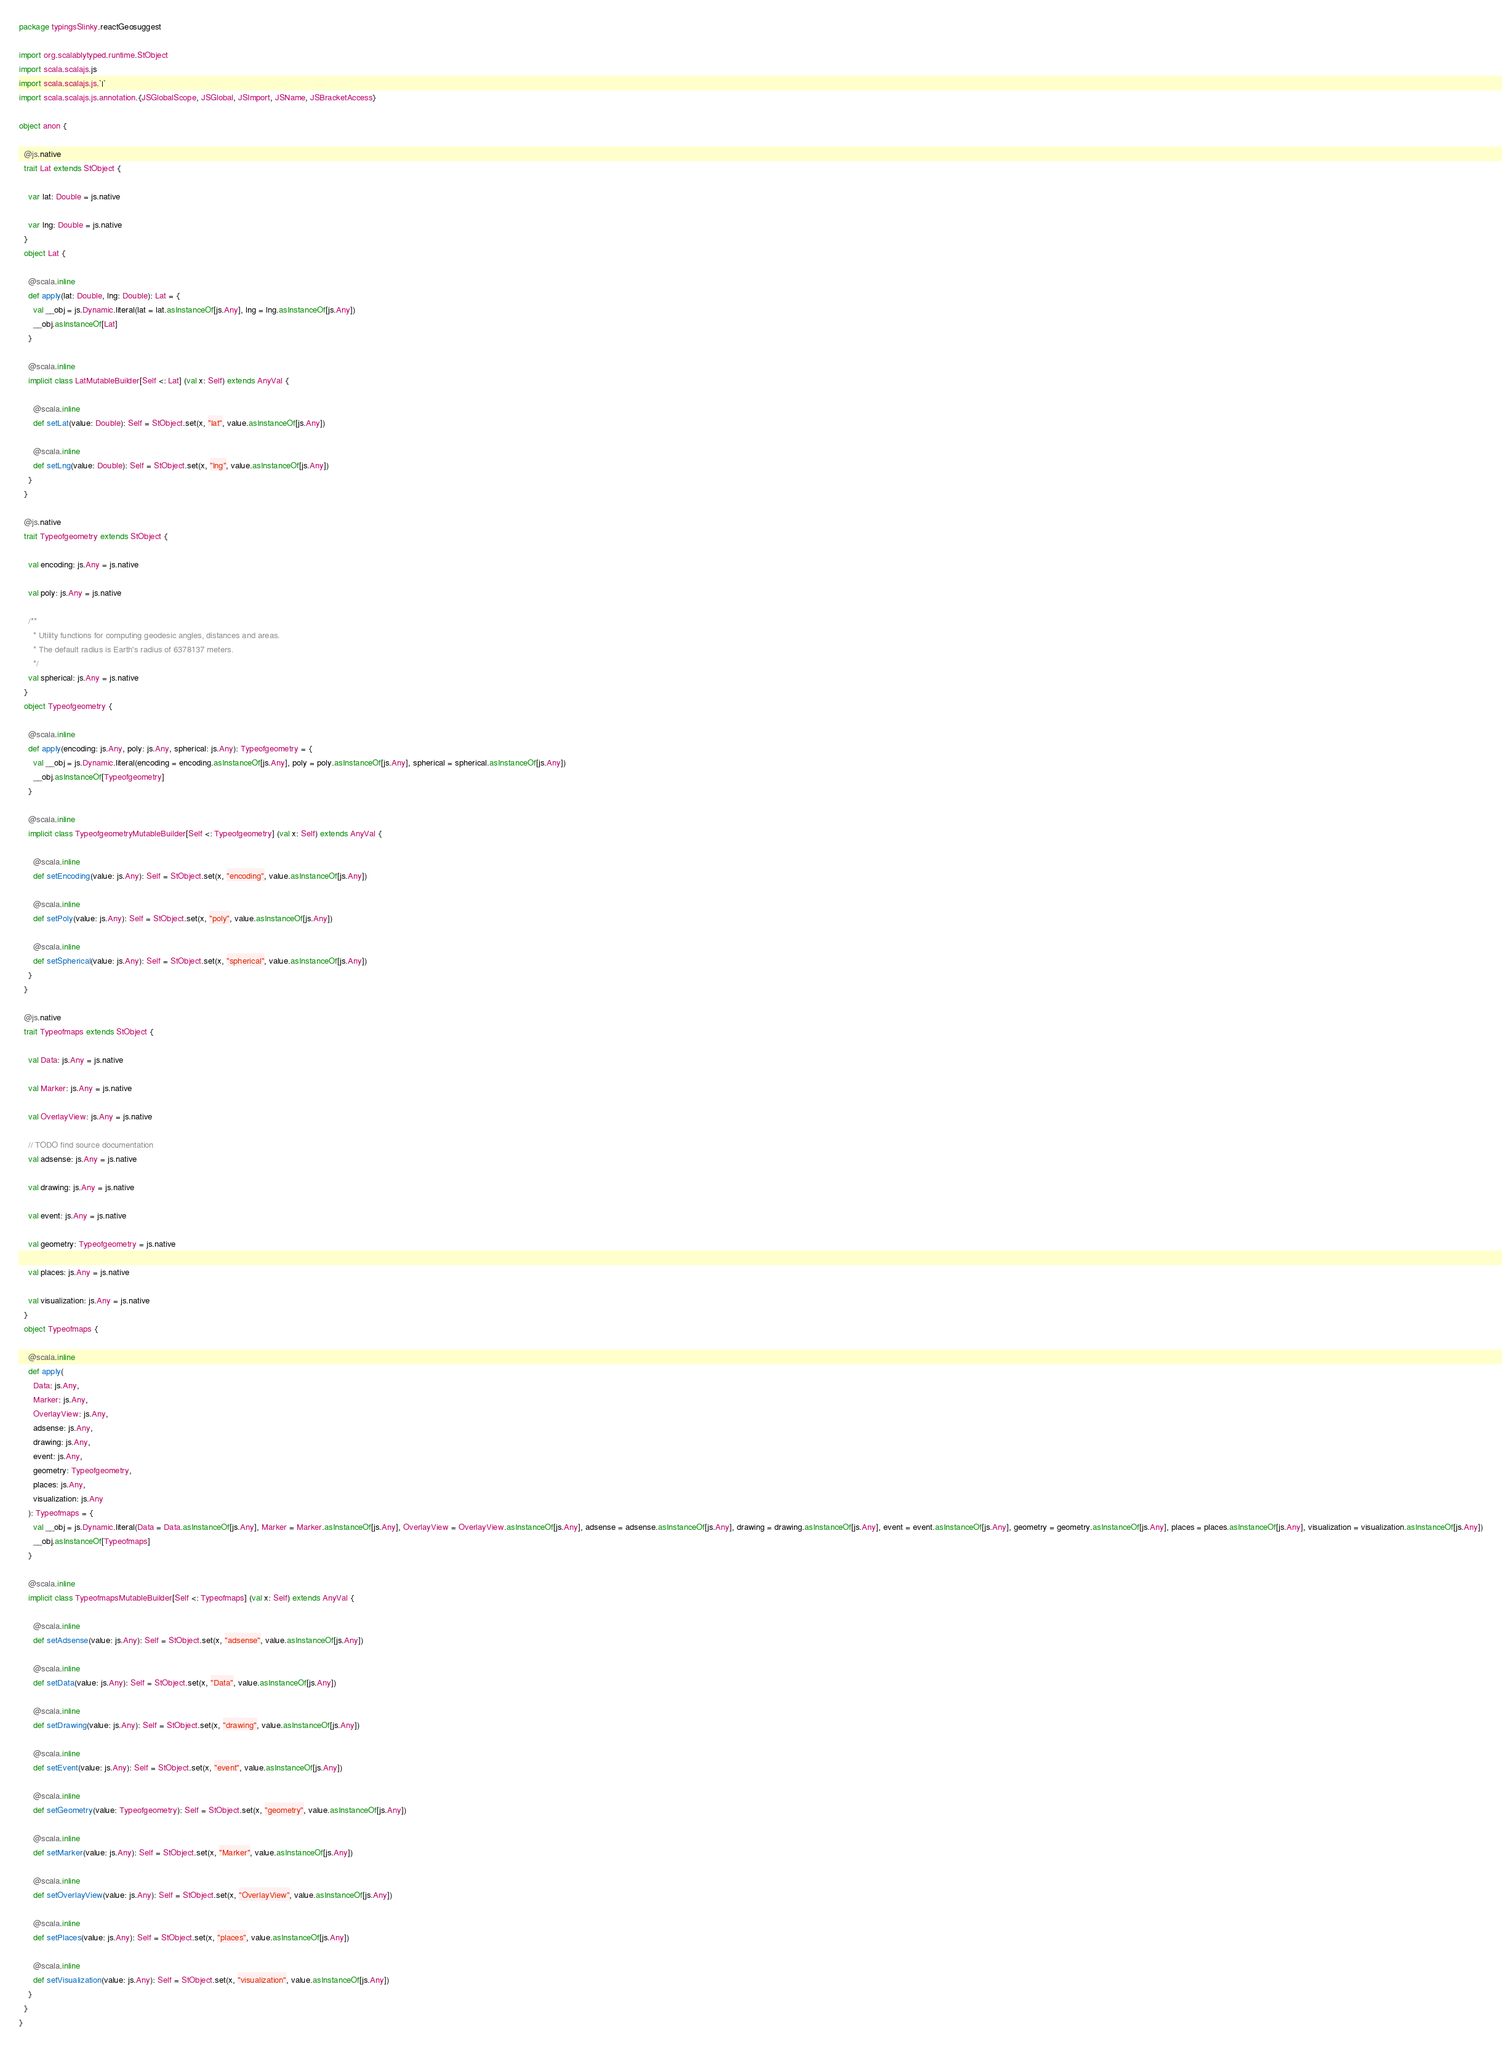<code> <loc_0><loc_0><loc_500><loc_500><_Scala_>package typingsSlinky.reactGeosuggest

import org.scalablytyped.runtime.StObject
import scala.scalajs.js
import scala.scalajs.js.`|`
import scala.scalajs.js.annotation.{JSGlobalScope, JSGlobal, JSImport, JSName, JSBracketAccess}

object anon {
  
  @js.native
  trait Lat extends StObject {
    
    var lat: Double = js.native
    
    var lng: Double = js.native
  }
  object Lat {
    
    @scala.inline
    def apply(lat: Double, lng: Double): Lat = {
      val __obj = js.Dynamic.literal(lat = lat.asInstanceOf[js.Any], lng = lng.asInstanceOf[js.Any])
      __obj.asInstanceOf[Lat]
    }
    
    @scala.inline
    implicit class LatMutableBuilder[Self <: Lat] (val x: Self) extends AnyVal {
      
      @scala.inline
      def setLat(value: Double): Self = StObject.set(x, "lat", value.asInstanceOf[js.Any])
      
      @scala.inline
      def setLng(value: Double): Self = StObject.set(x, "lng", value.asInstanceOf[js.Any])
    }
  }
  
  @js.native
  trait Typeofgeometry extends StObject {
    
    val encoding: js.Any = js.native
    
    val poly: js.Any = js.native
    
    /**
      * Utility functions for computing geodesic angles, distances and areas.
      * The default radius is Earth's radius of 6378137 meters.
      */
    val spherical: js.Any = js.native
  }
  object Typeofgeometry {
    
    @scala.inline
    def apply(encoding: js.Any, poly: js.Any, spherical: js.Any): Typeofgeometry = {
      val __obj = js.Dynamic.literal(encoding = encoding.asInstanceOf[js.Any], poly = poly.asInstanceOf[js.Any], spherical = spherical.asInstanceOf[js.Any])
      __obj.asInstanceOf[Typeofgeometry]
    }
    
    @scala.inline
    implicit class TypeofgeometryMutableBuilder[Self <: Typeofgeometry] (val x: Self) extends AnyVal {
      
      @scala.inline
      def setEncoding(value: js.Any): Self = StObject.set(x, "encoding", value.asInstanceOf[js.Any])
      
      @scala.inline
      def setPoly(value: js.Any): Self = StObject.set(x, "poly", value.asInstanceOf[js.Any])
      
      @scala.inline
      def setSpherical(value: js.Any): Self = StObject.set(x, "spherical", value.asInstanceOf[js.Any])
    }
  }
  
  @js.native
  trait Typeofmaps extends StObject {
    
    val Data: js.Any = js.native
    
    val Marker: js.Any = js.native
    
    val OverlayView: js.Any = js.native
    
    // TODO find source documentation
    val adsense: js.Any = js.native
    
    val drawing: js.Any = js.native
    
    val event: js.Any = js.native
    
    val geometry: Typeofgeometry = js.native
    
    val places: js.Any = js.native
    
    val visualization: js.Any = js.native
  }
  object Typeofmaps {
    
    @scala.inline
    def apply(
      Data: js.Any,
      Marker: js.Any,
      OverlayView: js.Any,
      adsense: js.Any,
      drawing: js.Any,
      event: js.Any,
      geometry: Typeofgeometry,
      places: js.Any,
      visualization: js.Any
    ): Typeofmaps = {
      val __obj = js.Dynamic.literal(Data = Data.asInstanceOf[js.Any], Marker = Marker.asInstanceOf[js.Any], OverlayView = OverlayView.asInstanceOf[js.Any], adsense = adsense.asInstanceOf[js.Any], drawing = drawing.asInstanceOf[js.Any], event = event.asInstanceOf[js.Any], geometry = geometry.asInstanceOf[js.Any], places = places.asInstanceOf[js.Any], visualization = visualization.asInstanceOf[js.Any])
      __obj.asInstanceOf[Typeofmaps]
    }
    
    @scala.inline
    implicit class TypeofmapsMutableBuilder[Self <: Typeofmaps] (val x: Self) extends AnyVal {
      
      @scala.inline
      def setAdsense(value: js.Any): Self = StObject.set(x, "adsense", value.asInstanceOf[js.Any])
      
      @scala.inline
      def setData(value: js.Any): Self = StObject.set(x, "Data", value.asInstanceOf[js.Any])
      
      @scala.inline
      def setDrawing(value: js.Any): Self = StObject.set(x, "drawing", value.asInstanceOf[js.Any])
      
      @scala.inline
      def setEvent(value: js.Any): Self = StObject.set(x, "event", value.asInstanceOf[js.Any])
      
      @scala.inline
      def setGeometry(value: Typeofgeometry): Self = StObject.set(x, "geometry", value.asInstanceOf[js.Any])
      
      @scala.inline
      def setMarker(value: js.Any): Self = StObject.set(x, "Marker", value.asInstanceOf[js.Any])
      
      @scala.inline
      def setOverlayView(value: js.Any): Self = StObject.set(x, "OverlayView", value.asInstanceOf[js.Any])
      
      @scala.inline
      def setPlaces(value: js.Any): Self = StObject.set(x, "places", value.asInstanceOf[js.Any])
      
      @scala.inline
      def setVisualization(value: js.Any): Self = StObject.set(x, "visualization", value.asInstanceOf[js.Any])
    }
  }
}
</code> 